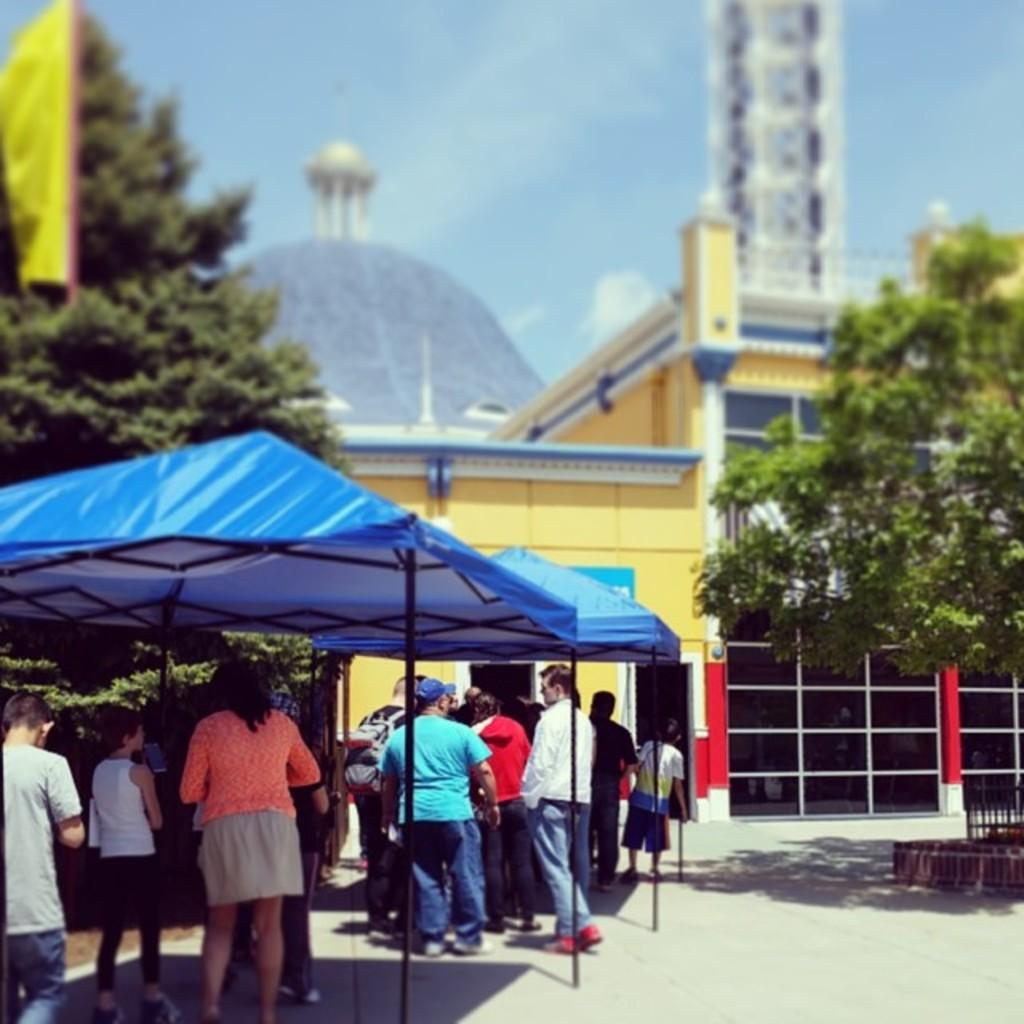Who or what can be seen in the image? There are people in the image. What structures are present in the image? There are tents in the image. What type of natural elements can be seen in the image? There are trees in the image. What architectural features are visible in the image? There is a fence and a wall in the image. What can be seen in the background of the image? There is a tower and the sky visible in the background of the image. What type of toothpaste is being used by the people in the image? There is no toothpaste present in the image; it features people, tents, trees, a fence, a wall, a tower, and the sky. Can you see any crayons being used by the people in the image? There are no crayons visible in the image. 